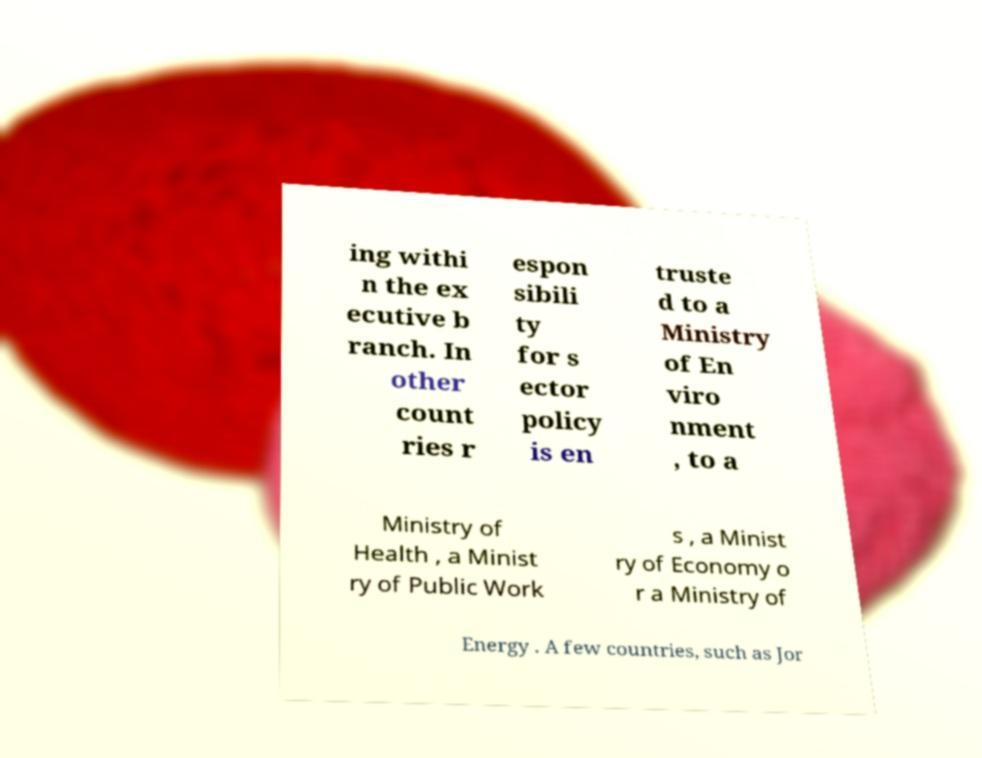I need the written content from this picture converted into text. Can you do that? ing withi n the ex ecutive b ranch. In other count ries r espon sibili ty for s ector policy is en truste d to a Ministry of En viro nment , to a Ministry of Health , a Minist ry of Public Work s , a Minist ry of Economy o r a Ministry of Energy . A few countries, such as Jor 